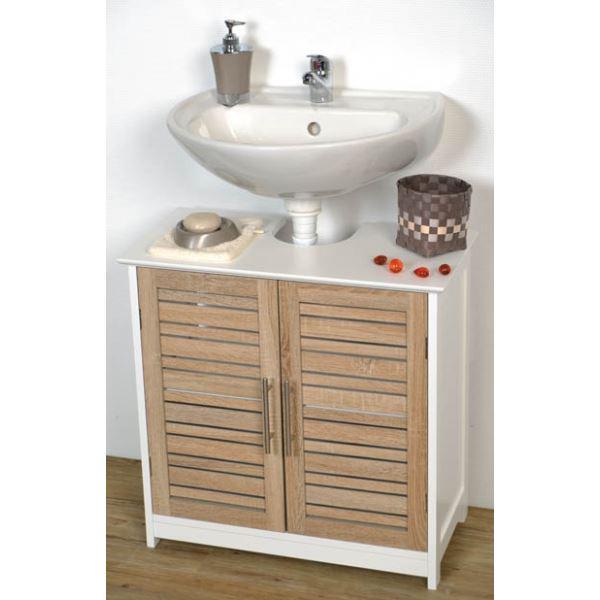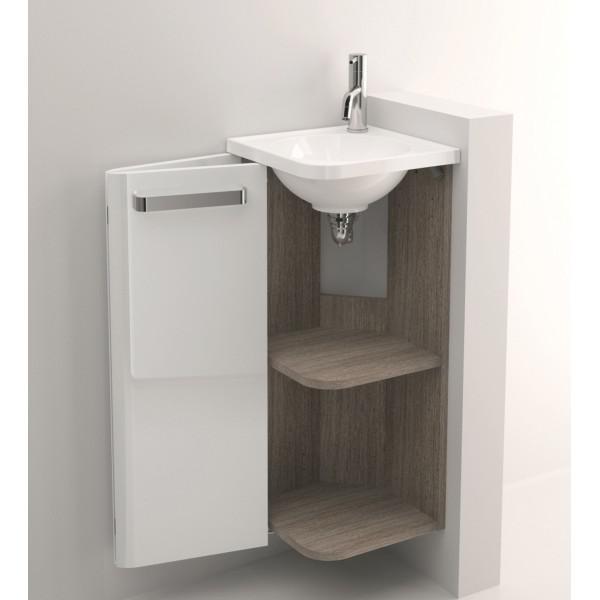The first image is the image on the left, the second image is the image on the right. Examine the images to the left and right. Is the description "The door on one of the cabinets is open." accurate? Answer yes or no. Yes. The first image is the image on the left, the second image is the image on the right. Examine the images to the left and right. Is the description "The left image features a white rectangular wall-mounted sink with its spout on the right side and a box shape underneath that does not extend to the floor." accurate? Answer yes or no. No. 